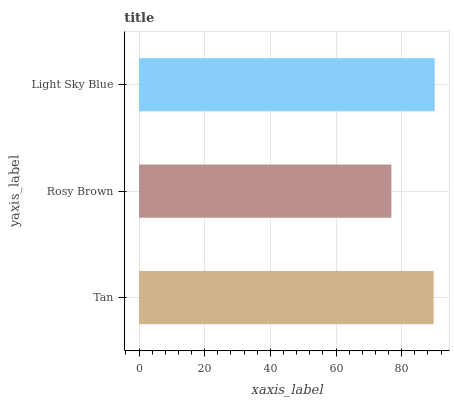Is Rosy Brown the minimum?
Answer yes or no. Yes. Is Light Sky Blue the maximum?
Answer yes or no. Yes. Is Light Sky Blue the minimum?
Answer yes or no. No. Is Rosy Brown the maximum?
Answer yes or no. No. Is Light Sky Blue greater than Rosy Brown?
Answer yes or no. Yes. Is Rosy Brown less than Light Sky Blue?
Answer yes or no. Yes. Is Rosy Brown greater than Light Sky Blue?
Answer yes or no. No. Is Light Sky Blue less than Rosy Brown?
Answer yes or no. No. Is Tan the high median?
Answer yes or no. Yes. Is Tan the low median?
Answer yes or no. Yes. Is Light Sky Blue the high median?
Answer yes or no. No. Is Light Sky Blue the low median?
Answer yes or no. No. 